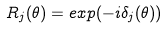Convert formula to latex. <formula><loc_0><loc_0><loc_500><loc_500>R _ { j } ( \theta ) = e x p ( - i \delta _ { j } ( \theta ) )</formula> 